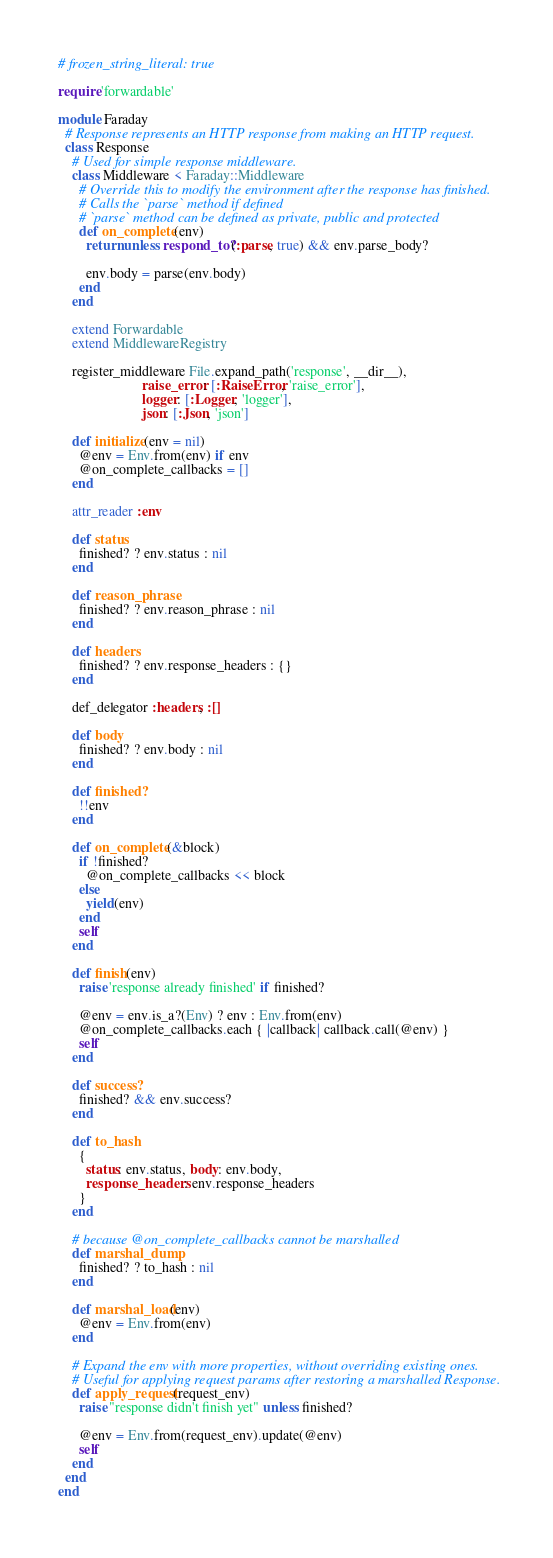Convert code to text. <code><loc_0><loc_0><loc_500><loc_500><_Ruby_># frozen_string_literal: true

require 'forwardable'

module Faraday
  # Response represents an HTTP response from making an HTTP request.
  class Response
    # Used for simple response middleware.
    class Middleware < Faraday::Middleware
      # Override this to modify the environment after the response has finished.
      # Calls the `parse` method if defined
      # `parse` method can be defined as private, public and protected
      def on_complete(env)
        return unless respond_to?(:parse, true) && env.parse_body?

        env.body = parse(env.body)
      end
    end

    extend Forwardable
    extend MiddlewareRegistry

    register_middleware File.expand_path('response', __dir__),
                        raise_error: [:RaiseError, 'raise_error'],
                        logger: [:Logger, 'logger'],
                        json: [:Json, 'json']

    def initialize(env = nil)
      @env = Env.from(env) if env
      @on_complete_callbacks = []
    end

    attr_reader :env

    def status
      finished? ? env.status : nil
    end

    def reason_phrase
      finished? ? env.reason_phrase : nil
    end

    def headers
      finished? ? env.response_headers : {}
    end

    def_delegator :headers, :[]

    def body
      finished? ? env.body : nil
    end

    def finished?
      !!env
    end

    def on_complete(&block)
      if !finished?
        @on_complete_callbacks << block
      else
        yield(env)
      end
      self
    end

    def finish(env)
      raise 'response already finished' if finished?

      @env = env.is_a?(Env) ? env : Env.from(env)
      @on_complete_callbacks.each { |callback| callback.call(@env) }
      self
    end

    def success?
      finished? && env.success?
    end

    def to_hash
      {
        status: env.status, body: env.body,
        response_headers: env.response_headers
      }
    end

    # because @on_complete_callbacks cannot be marshalled
    def marshal_dump
      finished? ? to_hash : nil
    end

    def marshal_load(env)
      @env = Env.from(env)
    end

    # Expand the env with more properties, without overriding existing ones.
    # Useful for applying request params after restoring a marshalled Response.
    def apply_request(request_env)
      raise "response didn't finish yet" unless finished?

      @env = Env.from(request_env).update(@env)
      self
    end
  end
end
</code> 